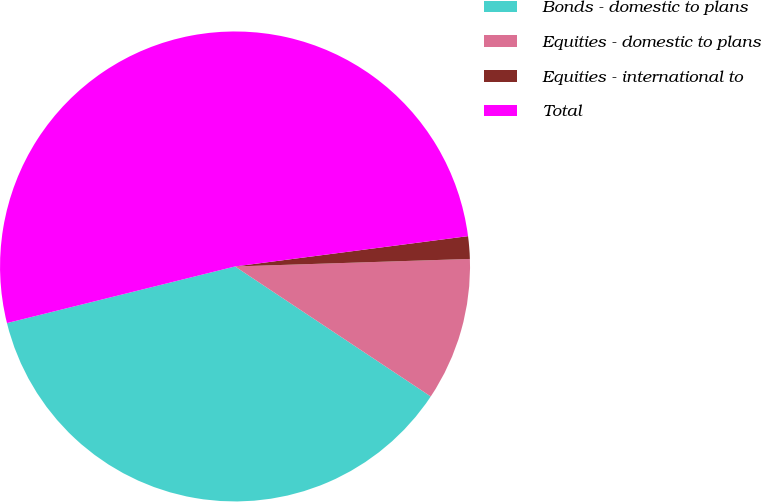Convert chart. <chart><loc_0><loc_0><loc_500><loc_500><pie_chart><fcel>Bonds - domestic to plans<fcel>Equities - domestic to plans<fcel>Equities - international to<fcel>Total<nl><fcel>36.79%<fcel>9.84%<fcel>1.55%<fcel>51.81%<nl></chart> 